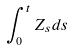Convert formula to latex. <formula><loc_0><loc_0><loc_500><loc_500>\int _ { 0 } ^ { t } Z _ { s } d s</formula> 